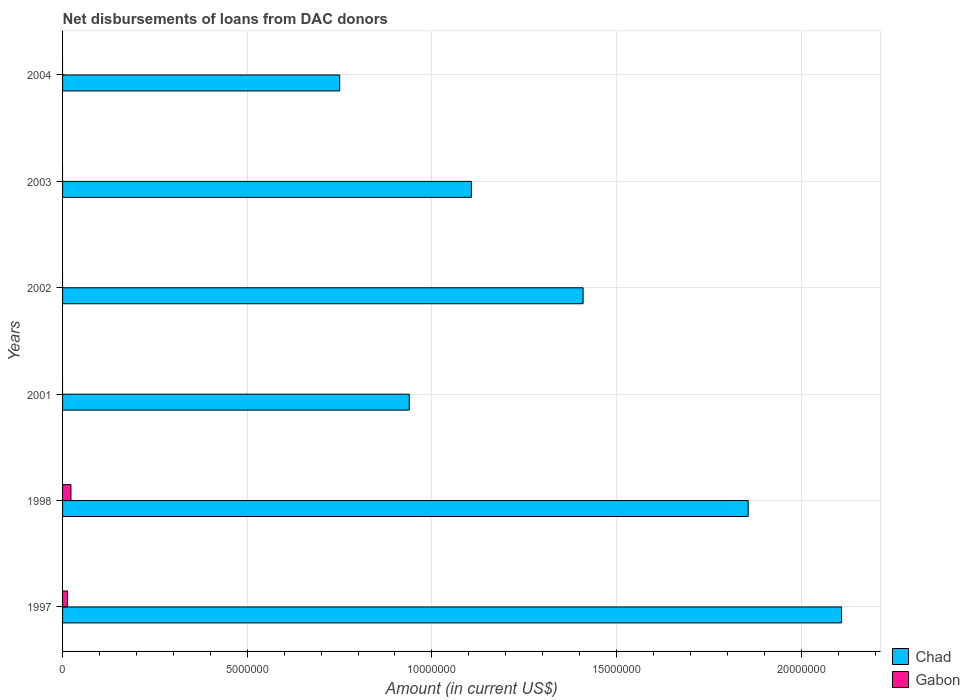How many different coloured bars are there?
Keep it short and to the point. 2. Are the number of bars on each tick of the Y-axis equal?
Provide a short and direct response. No. How many bars are there on the 5th tick from the top?
Provide a succinct answer. 2. How many bars are there on the 6th tick from the bottom?
Provide a succinct answer. 1. What is the amount of loans disbursed in Chad in 2004?
Offer a very short reply. 7.50e+06. Across all years, what is the maximum amount of loans disbursed in Chad?
Your answer should be very brief. 2.11e+07. Across all years, what is the minimum amount of loans disbursed in Gabon?
Your answer should be compact. 0. What is the total amount of loans disbursed in Gabon in the graph?
Your response must be concise. 3.60e+05. What is the difference between the amount of loans disbursed in Chad in 2001 and that in 2003?
Offer a terse response. -1.68e+06. What is the difference between the amount of loans disbursed in Gabon in 1998 and the amount of loans disbursed in Chad in 2003?
Your response must be concise. -1.08e+07. What is the average amount of loans disbursed in Gabon per year?
Provide a succinct answer. 6.00e+04. In the year 1997, what is the difference between the amount of loans disbursed in Chad and amount of loans disbursed in Gabon?
Your response must be concise. 2.10e+07. In how many years, is the amount of loans disbursed in Gabon greater than 5000000 US$?
Offer a very short reply. 0. What is the ratio of the amount of loans disbursed in Chad in 1998 to that in 2004?
Your response must be concise. 2.47. What is the difference between the highest and the lowest amount of loans disbursed in Chad?
Offer a very short reply. 1.36e+07. Are all the bars in the graph horizontal?
Your answer should be very brief. Yes. What is the difference between two consecutive major ticks on the X-axis?
Your answer should be very brief. 5.00e+06. Where does the legend appear in the graph?
Give a very brief answer. Bottom right. How many legend labels are there?
Ensure brevity in your answer.  2. What is the title of the graph?
Give a very brief answer. Net disbursements of loans from DAC donors. Does "Cyprus" appear as one of the legend labels in the graph?
Provide a succinct answer. No. What is the label or title of the X-axis?
Your answer should be very brief. Amount (in current US$). What is the label or title of the Y-axis?
Ensure brevity in your answer.  Years. What is the Amount (in current US$) in Chad in 1997?
Offer a terse response. 2.11e+07. What is the Amount (in current US$) in Gabon in 1997?
Ensure brevity in your answer.  1.33e+05. What is the Amount (in current US$) of Chad in 1998?
Ensure brevity in your answer.  1.86e+07. What is the Amount (in current US$) in Gabon in 1998?
Provide a succinct answer. 2.27e+05. What is the Amount (in current US$) in Chad in 2001?
Provide a short and direct response. 9.39e+06. What is the Amount (in current US$) of Gabon in 2001?
Your answer should be compact. 0. What is the Amount (in current US$) of Chad in 2002?
Provide a short and direct response. 1.41e+07. What is the Amount (in current US$) of Gabon in 2002?
Offer a terse response. 0. What is the Amount (in current US$) of Chad in 2003?
Provide a short and direct response. 1.11e+07. What is the Amount (in current US$) in Gabon in 2003?
Your response must be concise. 0. What is the Amount (in current US$) in Chad in 2004?
Your answer should be compact. 7.50e+06. Across all years, what is the maximum Amount (in current US$) of Chad?
Ensure brevity in your answer.  2.11e+07. Across all years, what is the maximum Amount (in current US$) in Gabon?
Offer a very short reply. 2.27e+05. Across all years, what is the minimum Amount (in current US$) in Chad?
Give a very brief answer. 7.50e+06. Across all years, what is the minimum Amount (in current US$) of Gabon?
Your answer should be compact. 0. What is the total Amount (in current US$) of Chad in the graph?
Ensure brevity in your answer.  8.17e+07. What is the total Amount (in current US$) of Gabon in the graph?
Provide a succinct answer. 3.60e+05. What is the difference between the Amount (in current US$) of Chad in 1997 and that in 1998?
Your answer should be compact. 2.53e+06. What is the difference between the Amount (in current US$) of Gabon in 1997 and that in 1998?
Ensure brevity in your answer.  -9.40e+04. What is the difference between the Amount (in current US$) in Chad in 1997 and that in 2001?
Make the answer very short. 1.17e+07. What is the difference between the Amount (in current US$) in Chad in 1997 and that in 2002?
Give a very brief answer. 7.00e+06. What is the difference between the Amount (in current US$) of Chad in 1997 and that in 2003?
Give a very brief answer. 1.00e+07. What is the difference between the Amount (in current US$) of Chad in 1997 and that in 2004?
Offer a terse response. 1.36e+07. What is the difference between the Amount (in current US$) in Chad in 1998 and that in 2001?
Offer a terse response. 9.18e+06. What is the difference between the Amount (in current US$) of Chad in 1998 and that in 2002?
Keep it short and to the point. 4.47e+06. What is the difference between the Amount (in current US$) of Chad in 1998 and that in 2003?
Ensure brevity in your answer.  7.50e+06. What is the difference between the Amount (in current US$) in Chad in 1998 and that in 2004?
Keep it short and to the point. 1.11e+07. What is the difference between the Amount (in current US$) in Chad in 2001 and that in 2002?
Provide a short and direct response. -4.71e+06. What is the difference between the Amount (in current US$) in Chad in 2001 and that in 2003?
Provide a short and direct response. -1.68e+06. What is the difference between the Amount (in current US$) of Chad in 2001 and that in 2004?
Provide a short and direct response. 1.88e+06. What is the difference between the Amount (in current US$) in Chad in 2002 and that in 2003?
Ensure brevity in your answer.  3.02e+06. What is the difference between the Amount (in current US$) of Chad in 2002 and that in 2004?
Offer a very short reply. 6.59e+06. What is the difference between the Amount (in current US$) in Chad in 2003 and that in 2004?
Your answer should be very brief. 3.57e+06. What is the difference between the Amount (in current US$) of Chad in 1997 and the Amount (in current US$) of Gabon in 1998?
Your answer should be very brief. 2.09e+07. What is the average Amount (in current US$) of Chad per year?
Your response must be concise. 1.36e+07. What is the average Amount (in current US$) in Gabon per year?
Your response must be concise. 6.00e+04. In the year 1997, what is the difference between the Amount (in current US$) in Chad and Amount (in current US$) in Gabon?
Your answer should be very brief. 2.10e+07. In the year 1998, what is the difference between the Amount (in current US$) in Chad and Amount (in current US$) in Gabon?
Offer a very short reply. 1.83e+07. What is the ratio of the Amount (in current US$) of Chad in 1997 to that in 1998?
Offer a very short reply. 1.14. What is the ratio of the Amount (in current US$) of Gabon in 1997 to that in 1998?
Offer a very short reply. 0.59. What is the ratio of the Amount (in current US$) in Chad in 1997 to that in 2001?
Keep it short and to the point. 2.25. What is the ratio of the Amount (in current US$) of Chad in 1997 to that in 2002?
Ensure brevity in your answer.  1.5. What is the ratio of the Amount (in current US$) in Chad in 1997 to that in 2003?
Provide a succinct answer. 1.91. What is the ratio of the Amount (in current US$) of Chad in 1997 to that in 2004?
Provide a short and direct response. 2.81. What is the ratio of the Amount (in current US$) of Chad in 1998 to that in 2001?
Offer a very short reply. 1.98. What is the ratio of the Amount (in current US$) in Chad in 1998 to that in 2002?
Offer a terse response. 1.32. What is the ratio of the Amount (in current US$) of Chad in 1998 to that in 2003?
Provide a succinct answer. 1.68. What is the ratio of the Amount (in current US$) of Chad in 1998 to that in 2004?
Keep it short and to the point. 2.47. What is the ratio of the Amount (in current US$) in Chad in 2001 to that in 2002?
Make the answer very short. 0.67. What is the ratio of the Amount (in current US$) of Chad in 2001 to that in 2003?
Your answer should be very brief. 0.85. What is the ratio of the Amount (in current US$) in Chad in 2001 to that in 2004?
Provide a short and direct response. 1.25. What is the ratio of the Amount (in current US$) in Chad in 2002 to that in 2003?
Your answer should be very brief. 1.27. What is the ratio of the Amount (in current US$) of Chad in 2002 to that in 2004?
Offer a terse response. 1.88. What is the ratio of the Amount (in current US$) in Chad in 2003 to that in 2004?
Offer a very short reply. 1.48. What is the difference between the highest and the second highest Amount (in current US$) of Chad?
Provide a succinct answer. 2.53e+06. What is the difference between the highest and the lowest Amount (in current US$) in Chad?
Give a very brief answer. 1.36e+07. What is the difference between the highest and the lowest Amount (in current US$) of Gabon?
Your answer should be very brief. 2.27e+05. 